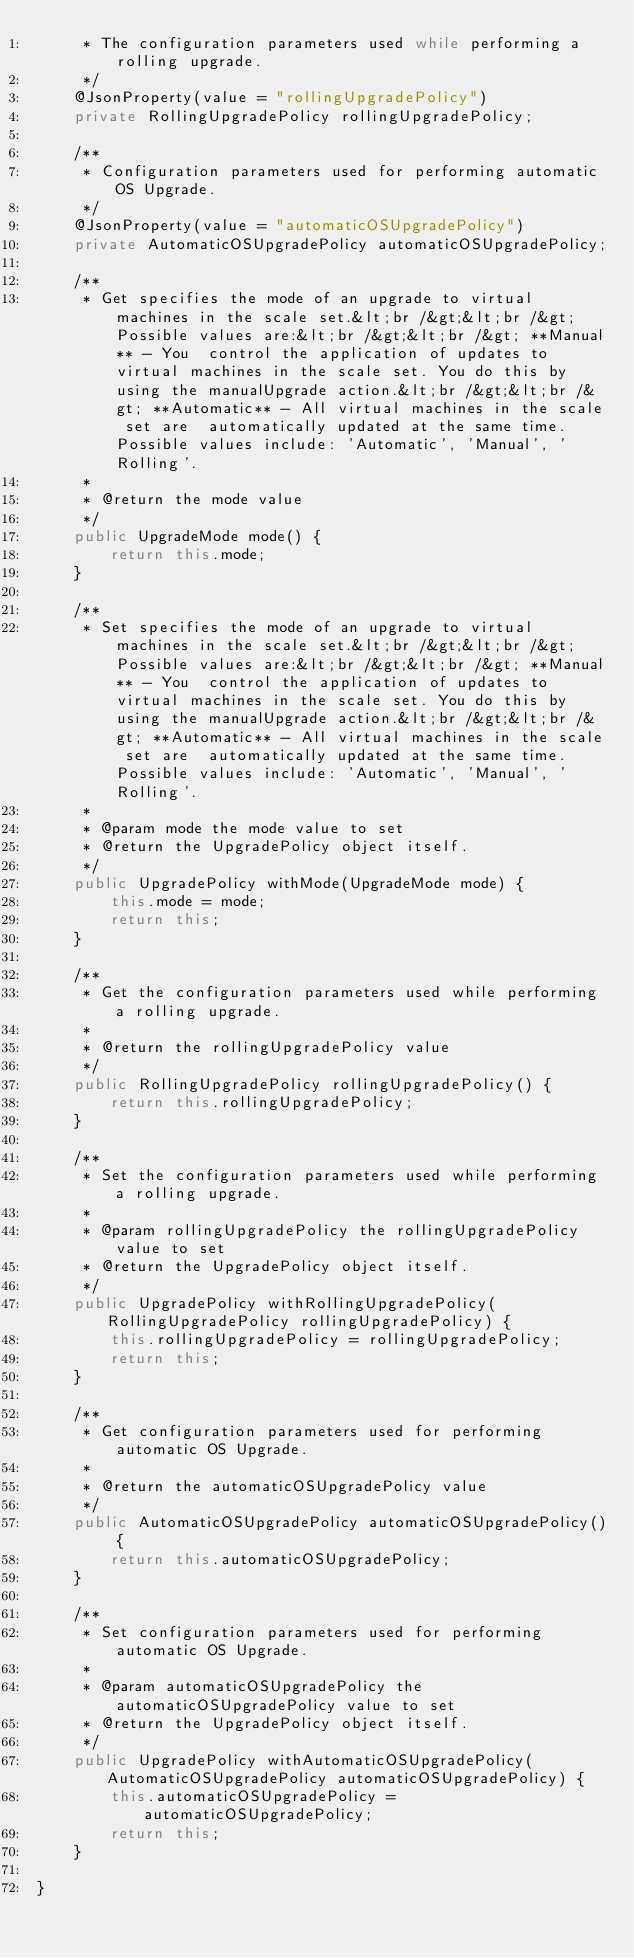<code> <loc_0><loc_0><loc_500><loc_500><_Java_>     * The configuration parameters used while performing a rolling upgrade.
     */
    @JsonProperty(value = "rollingUpgradePolicy")
    private RollingUpgradePolicy rollingUpgradePolicy;

    /**
     * Configuration parameters used for performing automatic OS Upgrade.
     */
    @JsonProperty(value = "automaticOSUpgradePolicy")
    private AutomaticOSUpgradePolicy automaticOSUpgradePolicy;

    /**
     * Get specifies the mode of an upgrade to virtual machines in the scale set.&lt;br /&gt;&lt;br /&gt; Possible values are:&lt;br /&gt;&lt;br /&gt; **Manual** - You  control the application of updates to virtual machines in the scale set. You do this by using the manualUpgrade action.&lt;br /&gt;&lt;br /&gt; **Automatic** - All virtual machines in the scale set are  automatically updated at the same time. Possible values include: 'Automatic', 'Manual', 'Rolling'.
     *
     * @return the mode value
     */
    public UpgradeMode mode() {
        return this.mode;
    }

    /**
     * Set specifies the mode of an upgrade to virtual machines in the scale set.&lt;br /&gt;&lt;br /&gt; Possible values are:&lt;br /&gt;&lt;br /&gt; **Manual** - You  control the application of updates to virtual machines in the scale set. You do this by using the manualUpgrade action.&lt;br /&gt;&lt;br /&gt; **Automatic** - All virtual machines in the scale set are  automatically updated at the same time. Possible values include: 'Automatic', 'Manual', 'Rolling'.
     *
     * @param mode the mode value to set
     * @return the UpgradePolicy object itself.
     */
    public UpgradePolicy withMode(UpgradeMode mode) {
        this.mode = mode;
        return this;
    }

    /**
     * Get the configuration parameters used while performing a rolling upgrade.
     *
     * @return the rollingUpgradePolicy value
     */
    public RollingUpgradePolicy rollingUpgradePolicy() {
        return this.rollingUpgradePolicy;
    }

    /**
     * Set the configuration parameters used while performing a rolling upgrade.
     *
     * @param rollingUpgradePolicy the rollingUpgradePolicy value to set
     * @return the UpgradePolicy object itself.
     */
    public UpgradePolicy withRollingUpgradePolicy(RollingUpgradePolicy rollingUpgradePolicy) {
        this.rollingUpgradePolicy = rollingUpgradePolicy;
        return this;
    }

    /**
     * Get configuration parameters used for performing automatic OS Upgrade.
     *
     * @return the automaticOSUpgradePolicy value
     */
    public AutomaticOSUpgradePolicy automaticOSUpgradePolicy() {
        return this.automaticOSUpgradePolicy;
    }

    /**
     * Set configuration parameters used for performing automatic OS Upgrade.
     *
     * @param automaticOSUpgradePolicy the automaticOSUpgradePolicy value to set
     * @return the UpgradePolicy object itself.
     */
    public UpgradePolicy withAutomaticOSUpgradePolicy(AutomaticOSUpgradePolicy automaticOSUpgradePolicy) {
        this.automaticOSUpgradePolicy = automaticOSUpgradePolicy;
        return this;
    }

}
</code> 